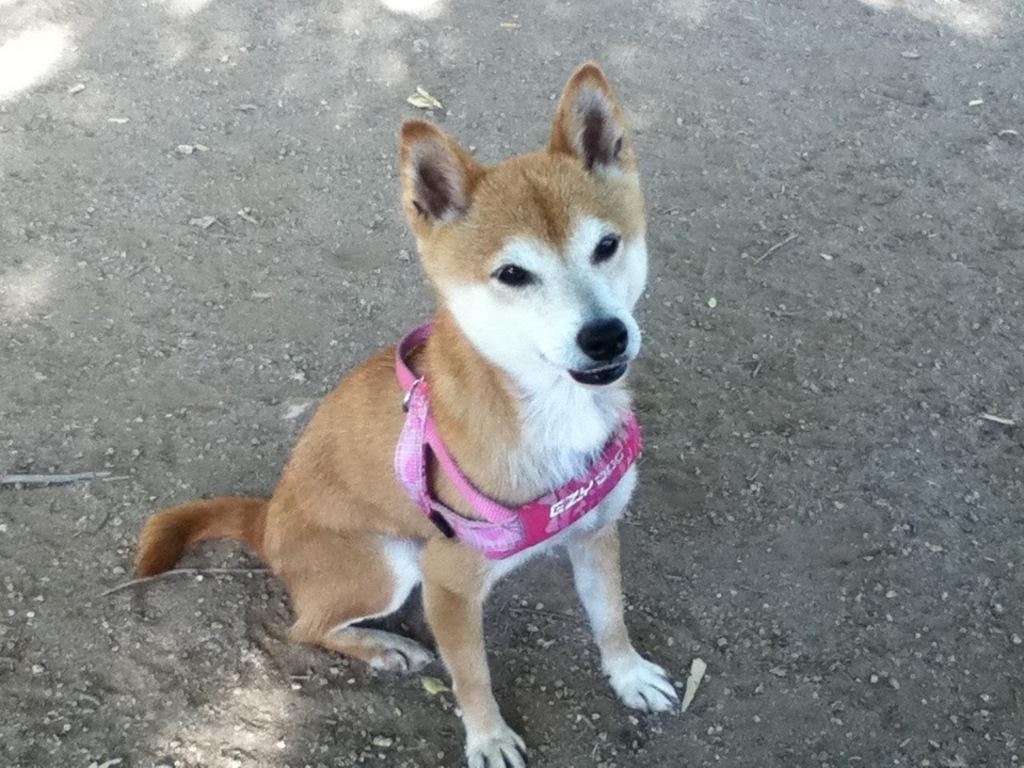What type of animal is in the image? There is a dog in the image. Can you describe the color of the dog? The dog is white and brown in color. What is the dog wearing in the image? The dog is wearing a pink color belt. Where is the dog located in the image? The dog is on the ground. What type of birds can be seen flying in the image? There are no birds visible in the image; it features a dog on the ground. What degree does the dog have in the image? The image does not depict the dog having a degree, as dogs do not obtain degrees. 